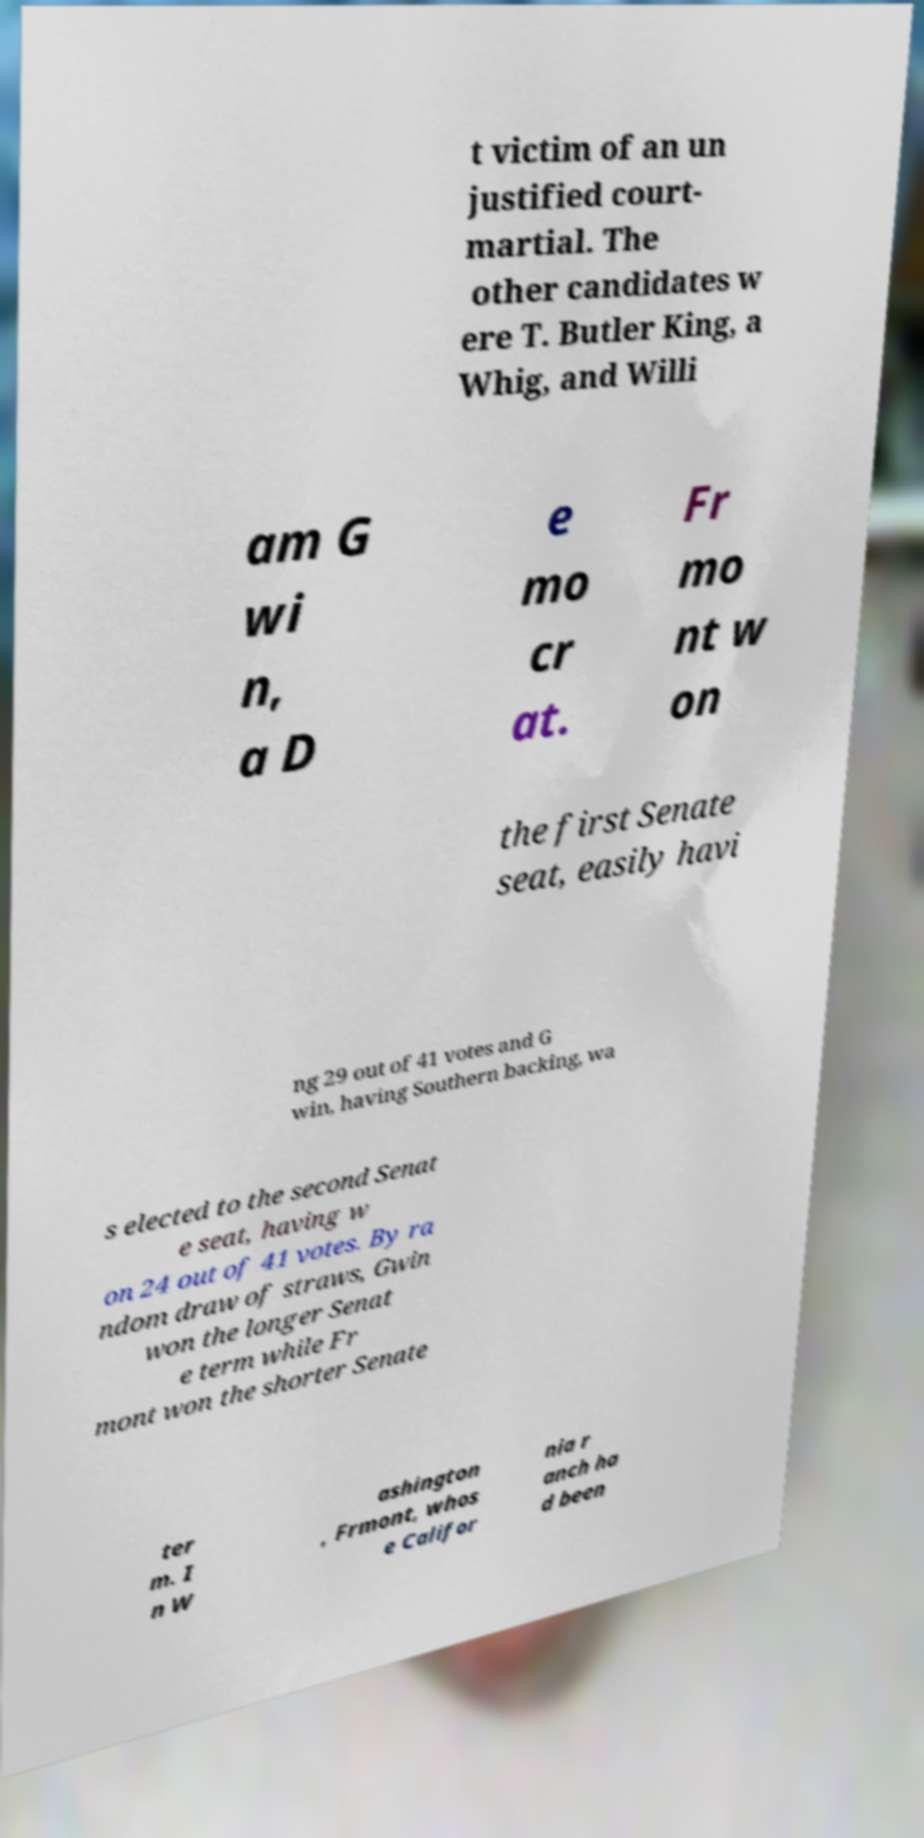Can you read and provide the text displayed in the image?This photo seems to have some interesting text. Can you extract and type it out for me? t victim of an un justified court- martial. The other candidates w ere T. Butler King, a Whig, and Willi am G wi n, a D e mo cr at. Fr mo nt w on the first Senate seat, easily havi ng 29 out of 41 votes and G win, having Southern backing, wa s elected to the second Senat e seat, having w on 24 out of 41 votes. By ra ndom draw of straws, Gwin won the longer Senat e term while Fr mont won the shorter Senate ter m. I n W ashington , Frmont, whos e Califor nia r anch ha d been 